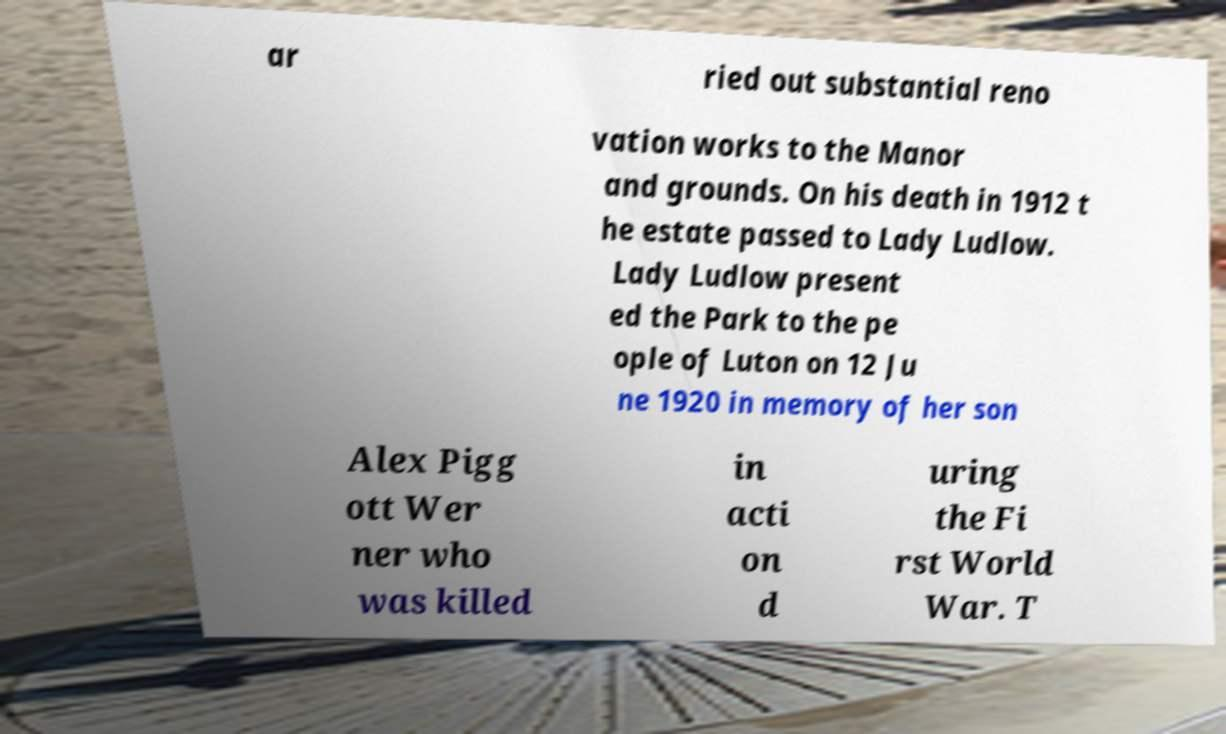What messages or text are displayed in this image? I need them in a readable, typed format. ar ried out substantial reno vation works to the Manor and grounds. On his death in 1912 t he estate passed to Lady Ludlow. Lady Ludlow present ed the Park to the pe ople of Luton on 12 Ju ne 1920 in memory of her son Alex Pigg ott Wer ner who was killed in acti on d uring the Fi rst World War. T 